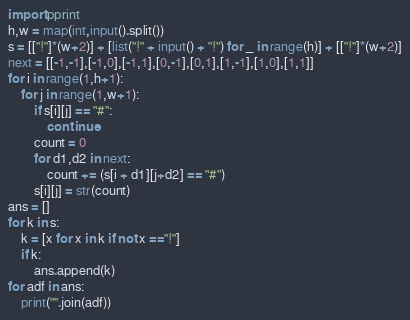<code> <loc_0><loc_0><loc_500><loc_500><_Python_>import pprint
h,w = map(int,input().split())
s = [["!"]*(w+2)] + [list("!" + input() + "!") for _ in range(h)] + [["!"]*(w+2)]
next = [[-1,-1],[-1,0],[-1,1],[0,-1],[0,1],[1,-1],[1,0],[1,1]]
for i in range(1,h+1):
    for j in range(1,w+1):
        if s[i][j] == "#":
            continue
        count = 0
        for d1,d2 in next:
            count += (s[i + d1][j+d2] == "#")
        s[i][j] = str(count)
ans = []
for k in s:
    k = [x for x in k if not x =="!"]
    if k:
        ans.append(k)
for adf in ans:
    print("".join(adf))
</code> 